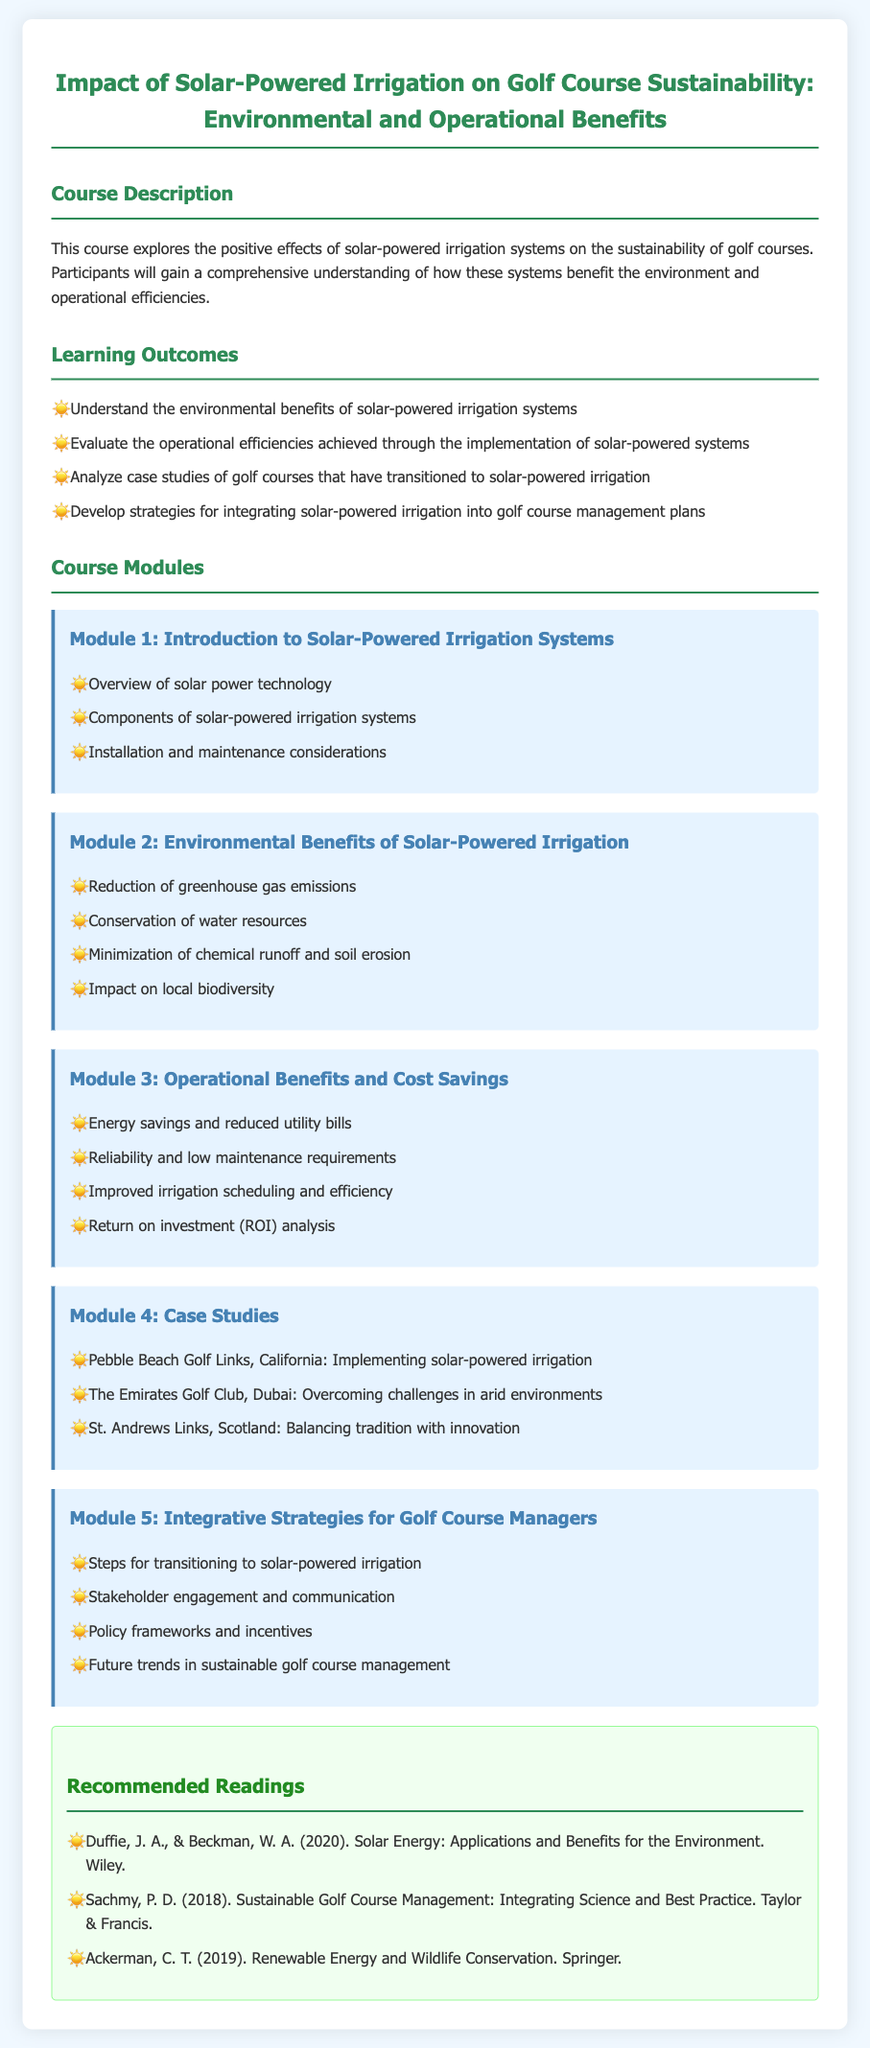What is the title of the course? The title of the course is stated at the beginning of the document.
Answer: Impact of Solar-Powered Irrigation on Golf Course Sustainability: Environmental and Operational Benefits What is the focus of Module 2? Module 2 specifically addresses the environmental benefits of solar-powered irrigation.
Answer: Environmental Benefits of Solar-Powered Irrigation How many learning outcomes are stated? The learning outcomes section lists the number of specific outcomes to be achieved.
Answer: Four What is one of the case studies mentioned in Module 4? The document lists several golf courses as examples in the case studies section.
Answer: Pebble Beach Golf Links, California: Implementing solar-powered irrigation Which reading is suggested by Ackerman? The readings section provides the names of authors and their works.
Answer: Renewable Energy and Wildlife Conservation What component is essential according to Module 1? Module 1 highlights crucial elements that make up solar-powered irrigation systems.
Answer: Components of solar-powered irrigation systems What is one operational benefit outlined in Module 3? Module 3 details specific advantages related to operations in golf courses.
Answer: Energy savings and reduced utility bills What is one strategy for golf course managers mentioned in Module 5? Module 5 provides steps for successful transition toward integrating solar-powered irrigation.
Answer: Steps for transitioning to solar-powered irrigation 